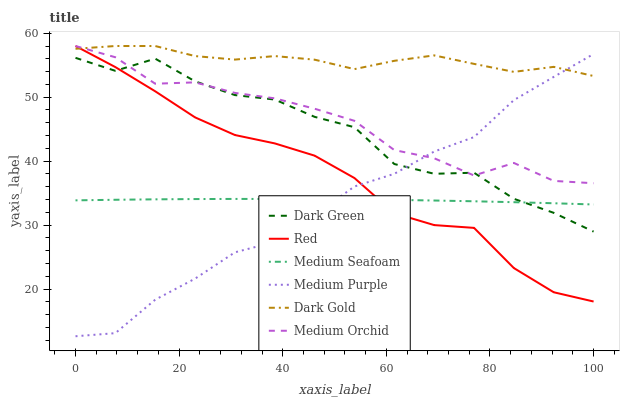Does Medium Purple have the minimum area under the curve?
Answer yes or no. Yes. Does Dark Gold have the maximum area under the curve?
Answer yes or no. Yes. Does Medium Orchid have the minimum area under the curve?
Answer yes or no. No. Does Medium Orchid have the maximum area under the curve?
Answer yes or no. No. Is Medium Seafoam the smoothest?
Answer yes or no. Yes. Is Dark Green the roughest?
Answer yes or no. Yes. Is Medium Orchid the smoothest?
Answer yes or no. No. Is Medium Orchid the roughest?
Answer yes or no. No. Does Medium Purple have the lowest value?
Answer yes or no. Yes. Does Medium Orchid have the lowest value?
Answer yes or no. No. Does Red have the highest value?
Answer yes or no. Yes. Does Medium Purple have the highest value?
Answer yes or no. No. Is Medium Seafoam less than Medium Orchid?
Answer yes or no. Yes. Is Dark Gold greater than Medium Seafoam?
Answer yes or no. Yes. Does Red intersect Medium Orchid?
Answer yes or no. Yes. Is Red less than Medium Orchid?
Answer yes or no. No. Is Red greater than Medium Orchid?
Answer yes or no. No. Does Medium Seafoam intersect Medium Orchid?
Answer yes or no. No. 